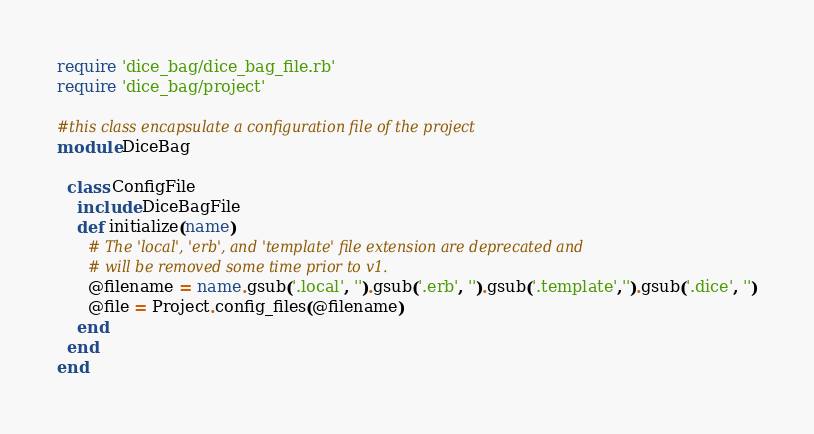<code> <loc_0><loc_0><loc_500><loc_500><_Ruby_>require 'dice_bag/dice_bag_file.rb'
require 'dice_bag/project'

#this class encapsulate a configuration file of the project
module DiceBag

  class ConfigFile
    include DiceBagFile
    def initialize(name)
      # The 'local', 'erb', and 'template' file extension are deprecated and
      # will be removed some time prior to v1.
      @filename = name.gsub('.local', '').gsub('.erb', '').gsub('.template','').gsub('.dice', '')
      @file = Project.config_files(@filename)
    end
  end
end
</code> 